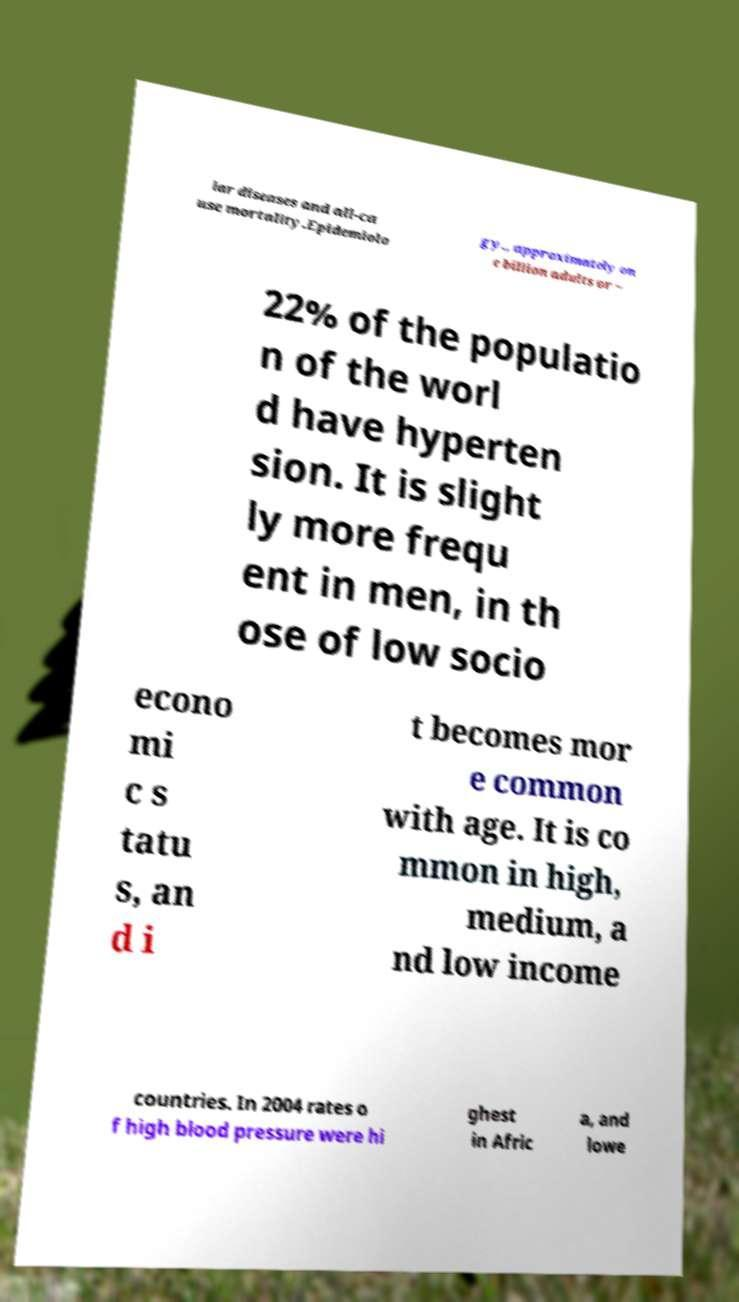Can you read and provide the text displayed in the image?This photo seems to have some interesting text. Can you extract and type it out for me? lar diseases and all-ca use mortality.Epidemiolo gy., approximately on e billion adults or ~ 22% of the populatio n of the worl d have hyperten sion. It is slight ly more frequ ent in men, in th ose of low socio econo mi c s tatu s, an d i t becomes mor e common with age. It is co mmon in high, medium, a nd low income countries. In 2004 rates o f high blood pressure were hi ghest in Afric a, and lowe 